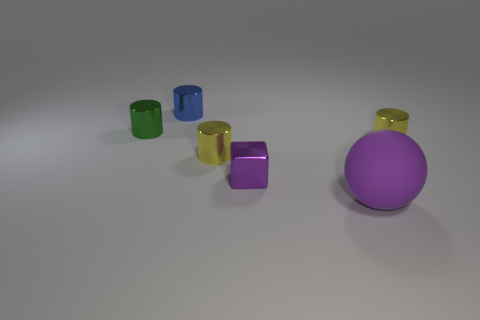There is a small cylinder on the left side of the blue thing; what number of cylinders are on the right side of it?
Your answer should be compact. 3. Are there fewer purple metallic blocks behind the blue cylinder than large brown cylinders?
Keep it short and to the point. No. Is there a blue metallic cylinder that is on the left side of the large matte object that is right of the tiny blue metallic cylinder that is to the left of the purple cube?
Your answer should be compact. Yes. Are the tiny green object and the object that is behind the green shiny object made of the same material?
Ensure brevity in your answer.  Yes. There is a small metallic cylinder that is on the left side of the metallic cylinder that is behind the tiny green metallic cylinder; what is its color?
Your answer should be compact. Green. Are there any objects that have the same color as the large matte ball?
Your answer should be very brief. Yes. What size is the yellow metal object that is behind the yellow metal cylinder left of the metal object that is on the right side of the big matte ball?
Provide a succinct answer. Small. There is a tiny purple thing; does it have the same shape as the yellow metal object left of the tiny purple object?
Keep it short and to the point. No. What number of other objects are the same size as the blue thing?
Keep it short and to the point. 4. How big is the purple sphere that is right of the small purple cube?
Give a very brief answer. Large. 